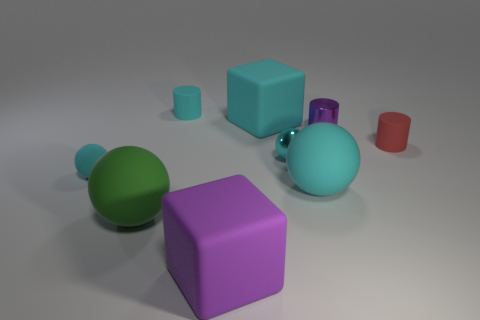How many cyan spheres must be subtracted to get 1 cyan spheres? 2 Subtract all cyan cylinders. How many cyan balls are left? 3 Subtract 2 spheres. How many spheres are left? 2 Add 1 gray cylinders. How many objects exist? 10 Subtract all green balls. How many balls are left? 3 Subtract all blue spheres. Subtract all green blocks. How many spheres are left? 4 Subtract all cylinders. How many objects are left? 6 Subtract all small red rubber cylinders. Subtract all cyan matte balls. How many objects are left? 6 Add 7 cyan cubes. How many cyan cubes are left? 8 Add 5 big green objects. How many big green objects exist? 6 